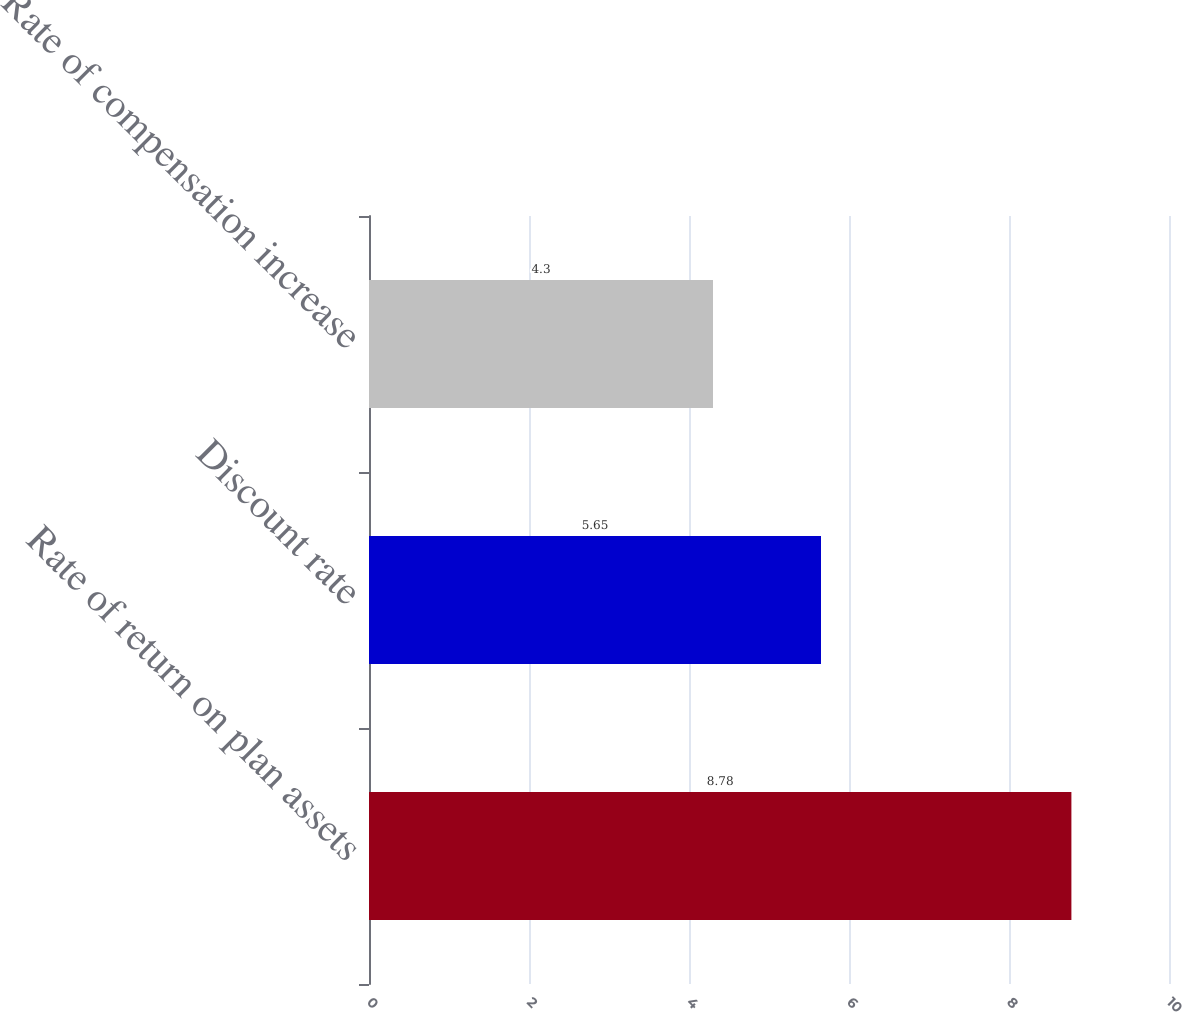Convert chart to OTSL. <chart><loc_0><loc_0><loc_500><loc_500><bar_chart><fcel>Rate of return on plan assets<fcel>Discount rate<fcel>Rate of compensation increase<nl><fcel>8.78<fcel>5.65<fcel>4.3<nl></chart> 